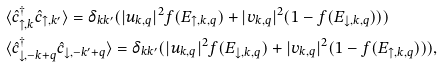<formula> <loc_0><loc_0><loc_500><loc_500>& \langle \hat { c } _ { \uparrow , { k } } ^ { \dagger } \hat { c } _ { \uparrow , { k ^ { \prime } } } \rangle = \delta _ { k k ^ { \prime } } ( | u _ { { k } , { q } } | ^ { 2 } f ( E _ { \uparrow , { k } , { q } } ) + | v _ { { k } , { q } } | ^ { 2 } ( 1 - f ( E _ { \downarrow , { k } , { q } } ) ) ) \\ & \langle \hat { c } _ { \downarrow , - { k } + { q } } ^ { \dagger } \hat { c } _ { \downarrow , - { k ^ { \prime } } + { q } } \rangle = \delta _ { k k ^ { \prime } } ( | u _ { { k } , { q } } | ^ { 2 } f ( E _ { \downarrow , { k } , { q } } ) + | v _ { { k } , { q } } | ^ { 2 } ( 1 - f ( E _ { \uparrow , { k } , { q } } ) ) ) ,</formula> 